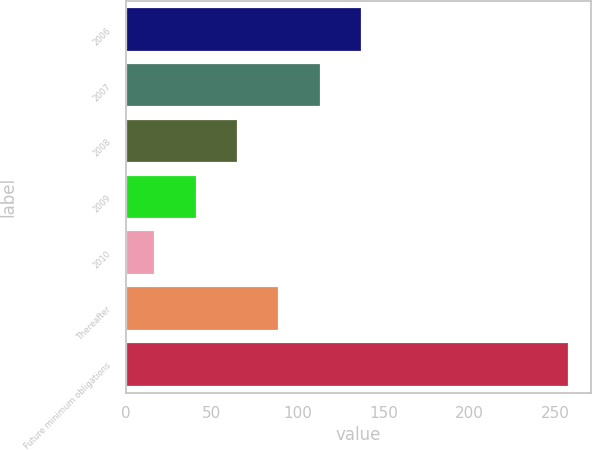<chart> <loc_0><loc_0><loc_500><loc_500><bar_chart><fcel>2006<fcel>2007<fcel>2008<fcel>2009<fcel>2010<fcel>Thereafter<fcel>Future minimum obligations<nl><fcel>137.4<fcel>113.34<fcel>65.22<fcel>41.16<fcel>17.1<fcel>89.28<fcel>257.7<nl></chart> 